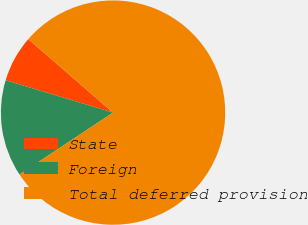Convert chart. <chart><loc_0><loc_0><loc_500><loc_500><pie_chart><fcel>State<fcel>Foreign<fcel>Total deferred provision<nl><fcel>6.71%<fcel>13.97%<fcel>79.31%<nl></chart> 